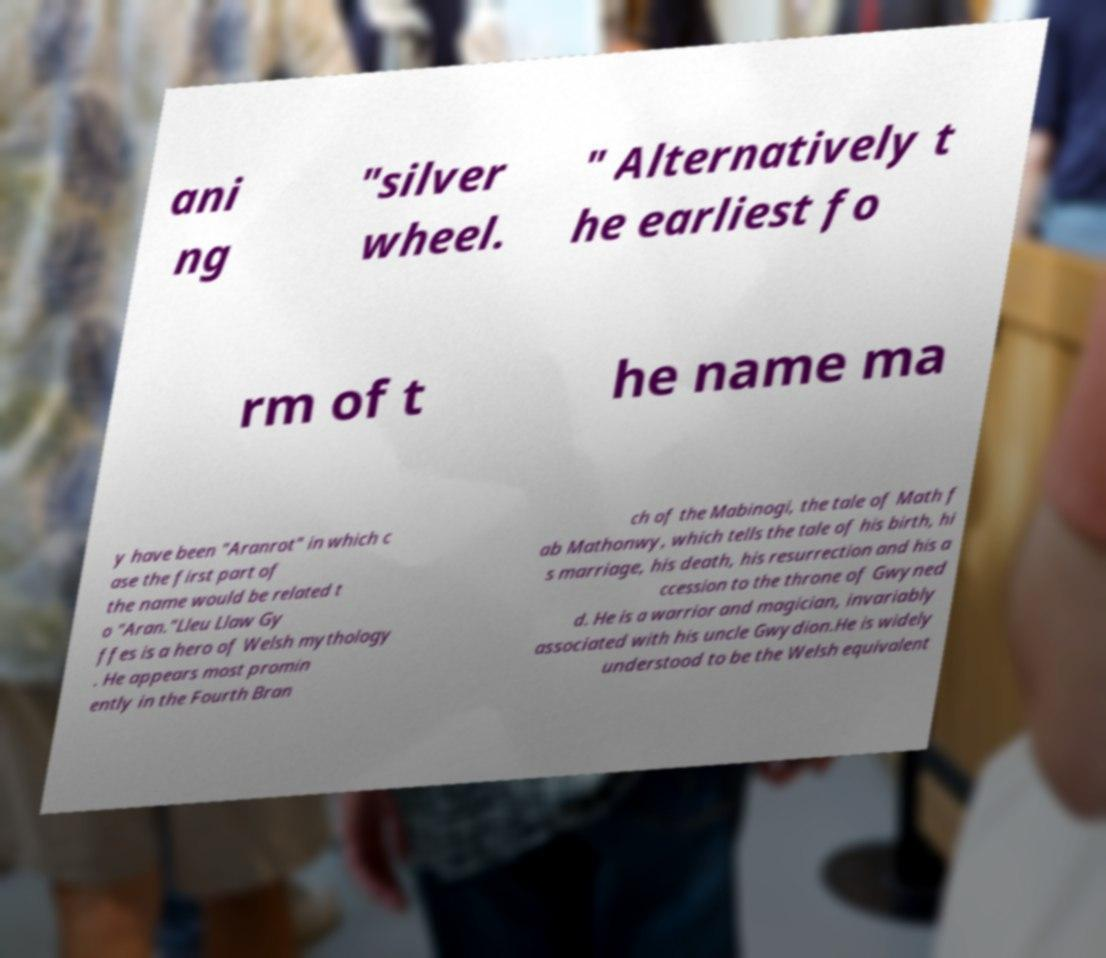Can you accurately transcribe the text from the provided image for me? ani ng "silver wheel. " Alternatively t he earliest fo rm of t he name ma y have been "Aranrot" in which c ase the first part of the name would be related t o "Aran."Lleu Llaw Gy ffes is a hero of Welsh mythology . He appears most promin ently in the Fourth Bran ch of the Mabinogi, the tale of Math f ab Mathonwy, which tells the tale of his birth, hi s marriage, his death, his resurrection and his a ccession to the throne of Gwyned d. He is a warrior and magician, invariably associated with his uncle Gwydion.He is widely understood to be the Welsh equivalent 